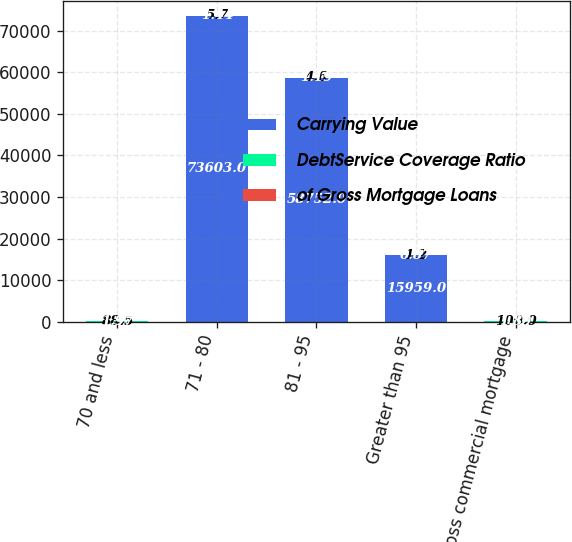<chart> <loc_0><loc_0><loc_500><loc_500><stacked_bar_chart><ecel><fcel>70 and less<fcel>71 - 80<fcel>81 - 95<fcel>Greater than 95<fcel>Gross commercial mortgage<nl><fcel>Carrying Value<fcel>4.6<fcel>73603<fcel>58752<fcel>15959<fcel>4.6<nl><fcel>DebtService Coverage Ratio<fcel>88.5<fcel>5.7<fcel>4.6<fcel>1.2<fcel>100<nl><fcel>of Gross Mortgage Loans<fcel>1.97<fcel>1.44<fcel>1.19<fcel>0.87<fcel>1.89<nl></chart> 